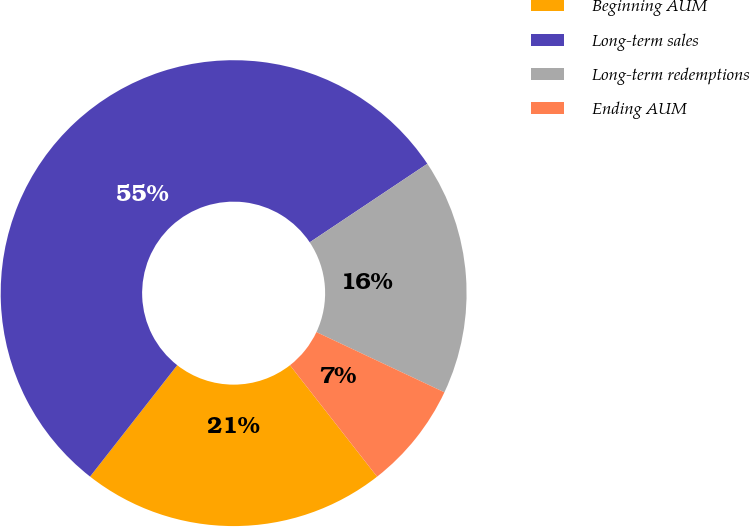<chart> <loc_0><loc_0><loc_500><loc_500><pie_chart><fcel>Beginning AUM<fcel>Long-term sales<fcel>Long-term redemptions<fcel>Ending AUM<nl><fcel>21.13%<fcel>55.06%<fcel>16.37%<fcel>7.44%<nl></chart> 